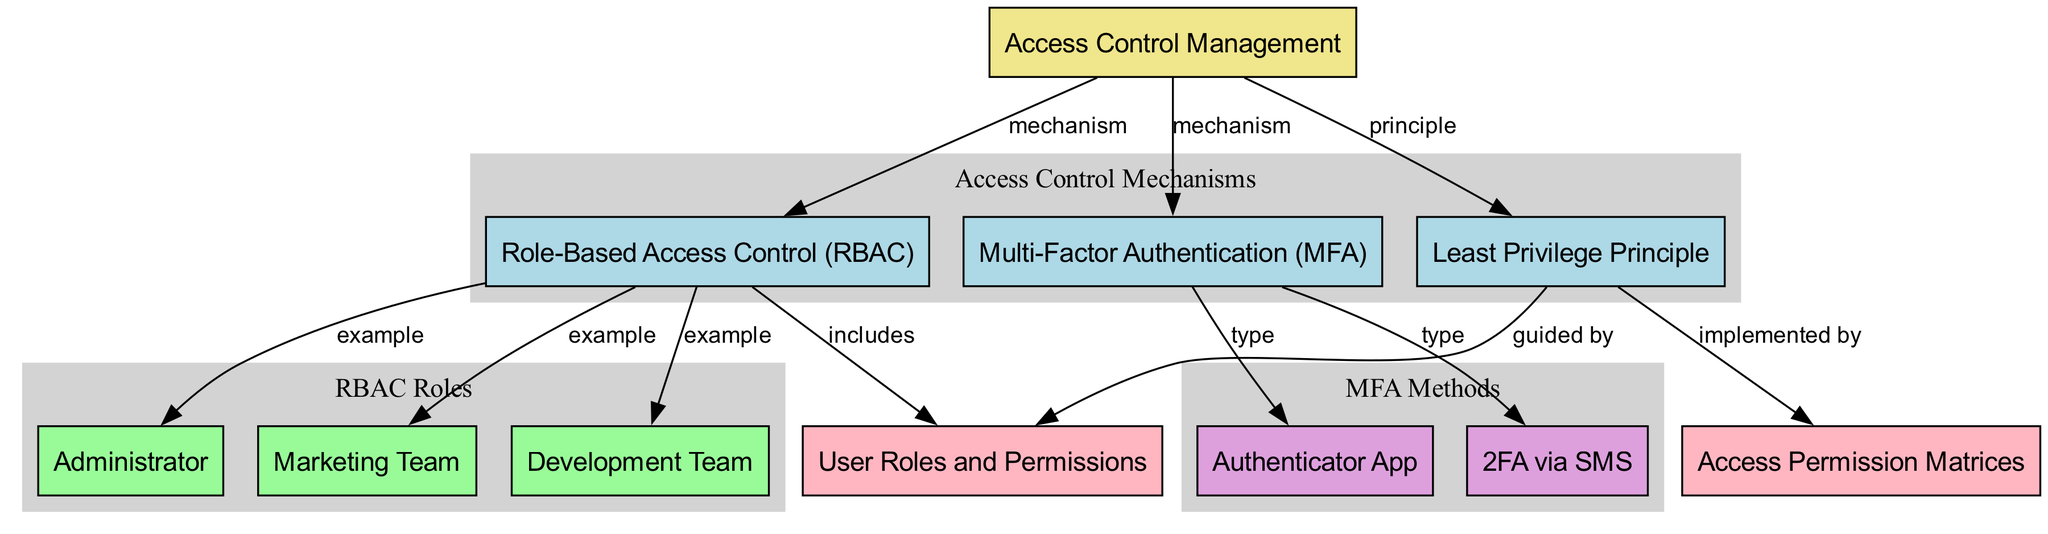What is the main subject of the diagram? The diagram's main subject is labeled as "Access Control Management," which is the focal point from which all other concepts and mechanisms branch out.
Answer: Access Control Management How many sub-mechanisms are listed in the diagram? The diagram features three sub-mechanisms connected to the main subject: Role-Based Access Control, Multi-Factor Authentication, and Least Privilege Principle.
Answer: 3 Which role is associated with Role-Based Access Control? The diagram shows that Administrator, Marketing Team, and Development Team are examples of roles that fall under Role-Based Access Control, indicating their relationship as part of the role management approach.
Answer: Administrator, Marketing Team, Development Team Which method is associated with Multi-Factor Authentication? The diagram indicates two methods associated with Multi-Factor Authentication: 2FA via SMS and Authenticator App. These are explicitly linked as types of MFA in the diagram.
Answer: 2FA via SMS, Authenticator App What principle is guided by User Roles and Permissions? The principle of Least Privilege is guided by User Roles and Permissions, as indicated in the diagram where it states that the principle is based on how roles are defined and assigned permissions.
Answer: Least Privilege Principle How many connections lead from the main subject to sub-mechanisms? The main subject "Access Control Management" connects to three sub-mechanisms (Role-Based Access Control, Multi-Factor Authentication, and Least Privilege Principle), indicating a well-structured hierarchy of access controls.
Answer: 3 Which concept is implemented by the Least Privilege Principle? Access Permission Matrices, which help specify the exact permissions granted to each role within a system, is the concept that the Least Privilege Principle is implemented by.
Answer: Access Permission Matrices What type of access control does RBAC represent? Role-Based Access Control (RBAC) is a type of access control mechanism defined in the diagram, which organizes permissions based on user roles within an organization.
Answer: mechanism Which color represents the concept in this diagram? In the diagram, concepts are represented by the color pink (#FFB6C1), which distinguishes them from other node types, allowing for visual differentiation.
Answer: pink 